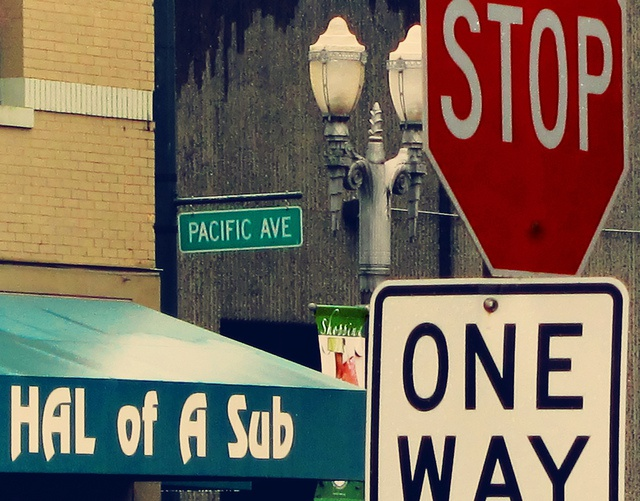Describe the objects in this image and their specific colors. I can see a stop sign in brown, maroon, darkgray, and gray tones in this image. 